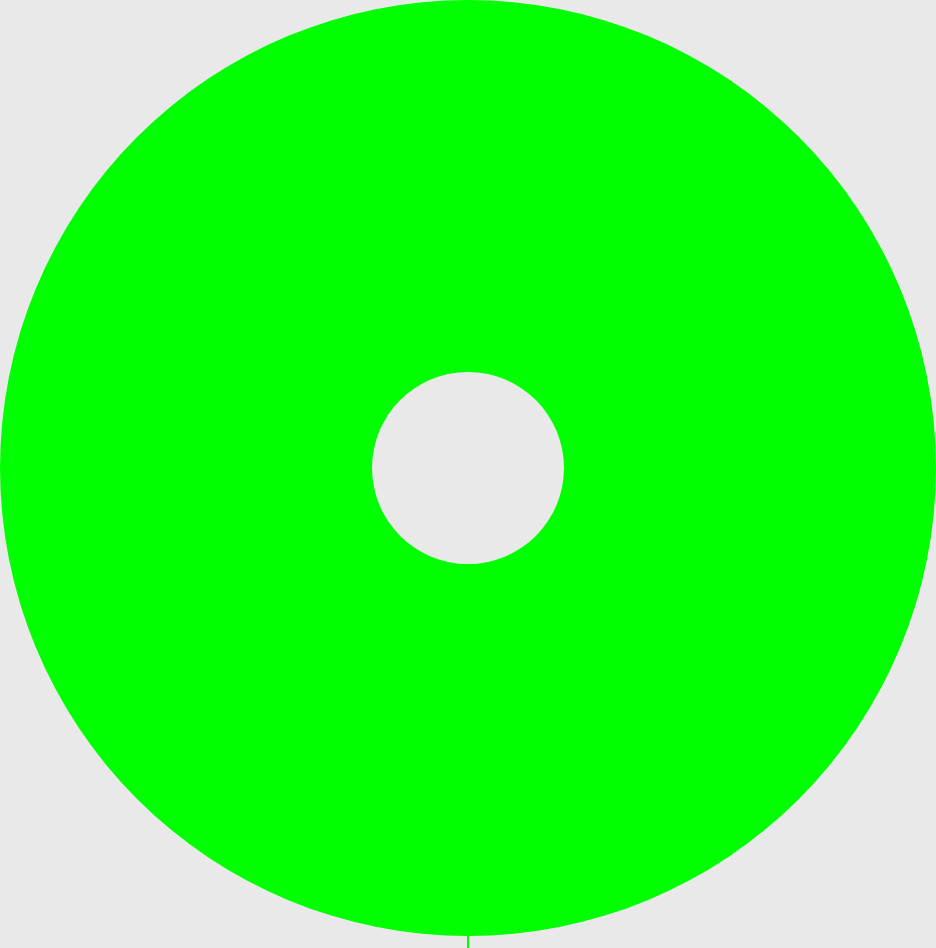Convert chart. <chart><loc_0><loc_0><loc_500><loc_500><pie_chart><fcel>Income available to common<nl><fcel>100.0%<nl></chart> 